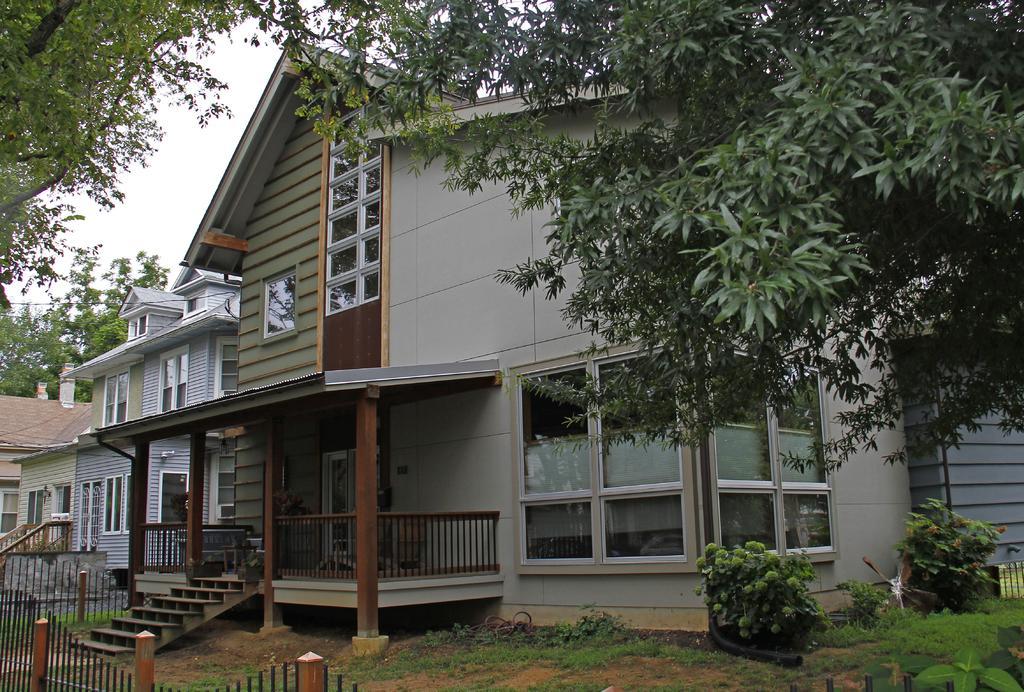Could you give a brief overview of what you see in this image? In this image there are buildings and trees. Image also consists of plants, stairs and also fence. Sky is also visible. 